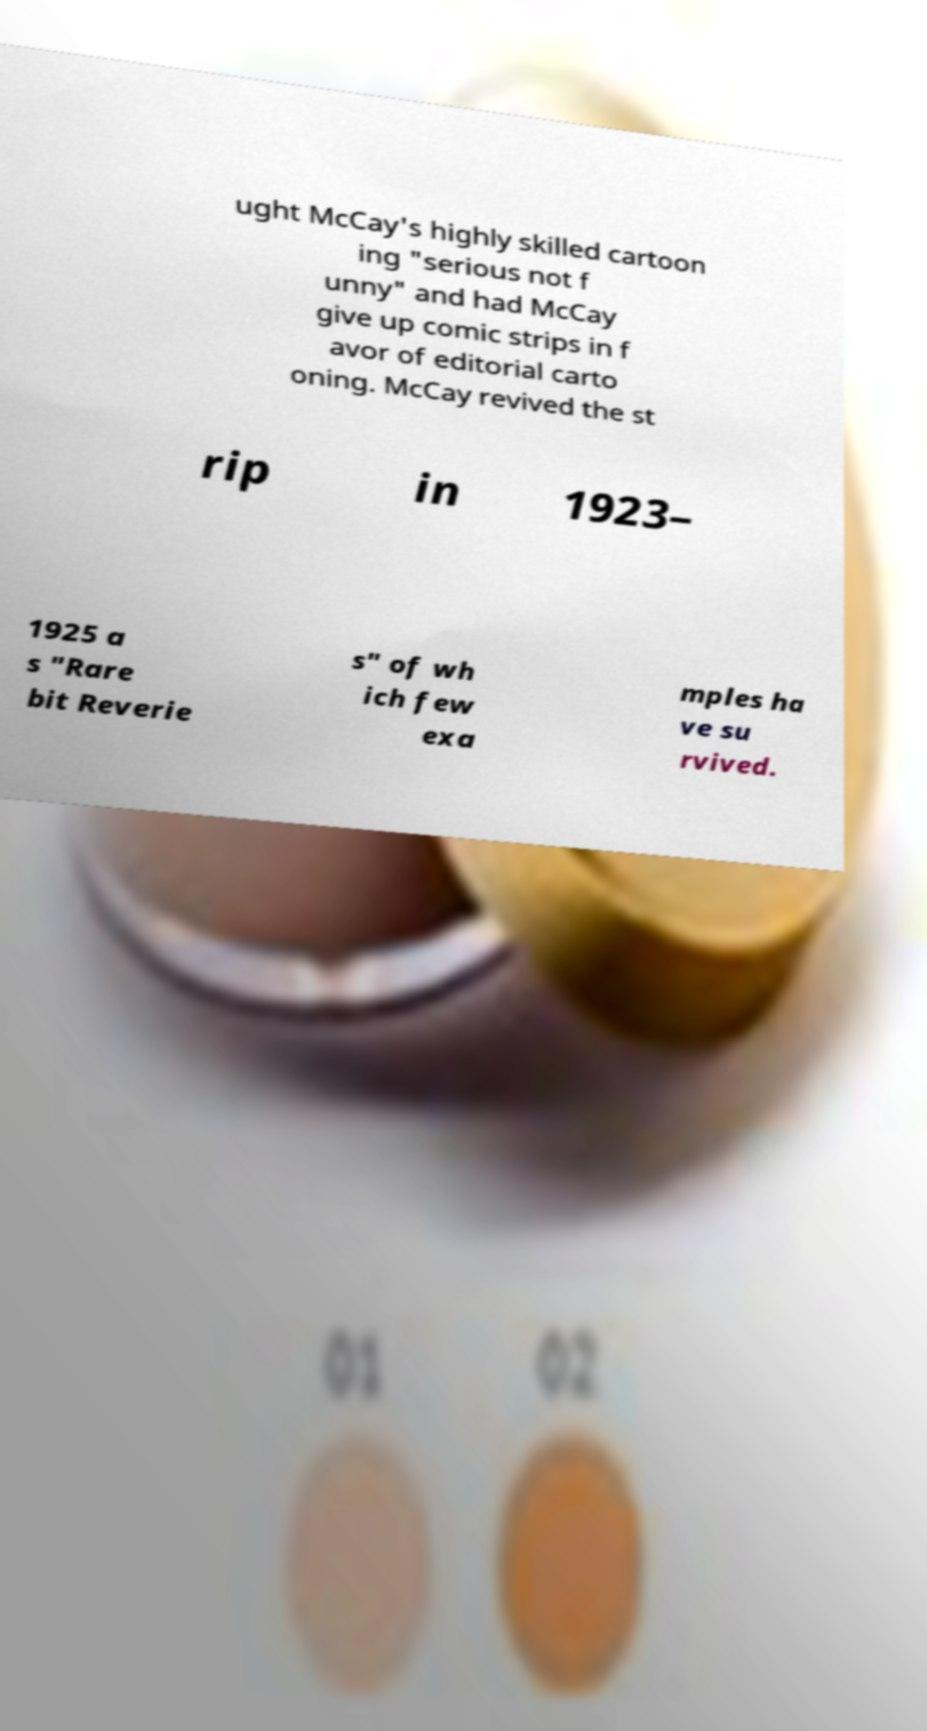What messages or text are displayed in this image? I need them in a readable, typed format. ught McCay's highly skilled cartoon ing "serious not f unny" and had McCay give up comic strips in f avor of editorial carto oning. McCay revived the st rip in 1923– 1925 a s "Rare bit Reverie s" of wh ich few exa mples ha ve su rvived. 